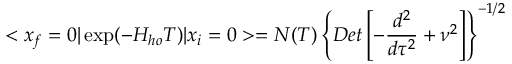Convert formula to latex. <formula><loc_0><loc_0><loc_500><loc_500>< x _ { f } = 0 | \exp ( - H _ { h o } T ) | x _ { i } = 0 > = N ( T ) \left \{ D e t \left [ - { \frac { d ^ { 2 } } { d \tau ^ { 2 } } } + \nu ^ { 2 } \right ] \right \} ^ { - 1 / 2 }</formula> 